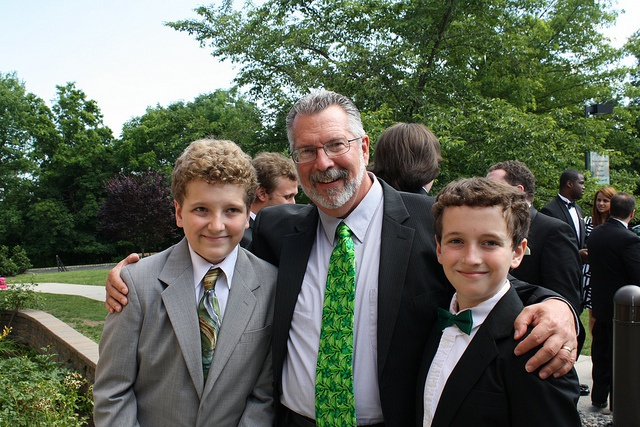Describe the objects in this image and their specific colors. I can see people in lightblue, black, darkgray, gray, and lightgray tones, people in lightblue, gray, and black tones, people in lightblue, black, gray, and lavender tones, tie in lightblue, darkgreen, green, and darkgray tones, and people in lightblue, black, gray, and maroon tones in this image. 